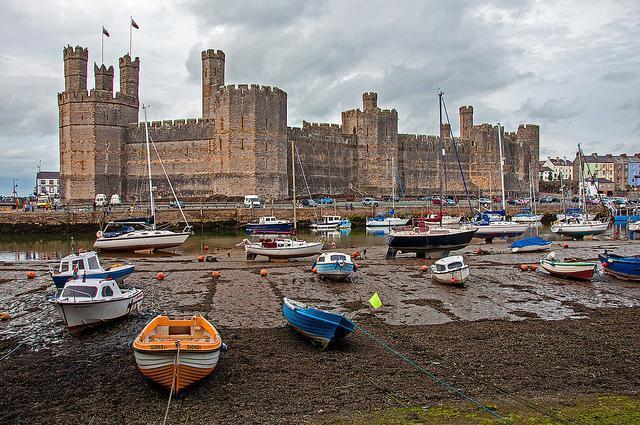How many boats are there?
Give a very brief answer. 6. How many umbrellas are there?
Give a very brief answer. 0. 